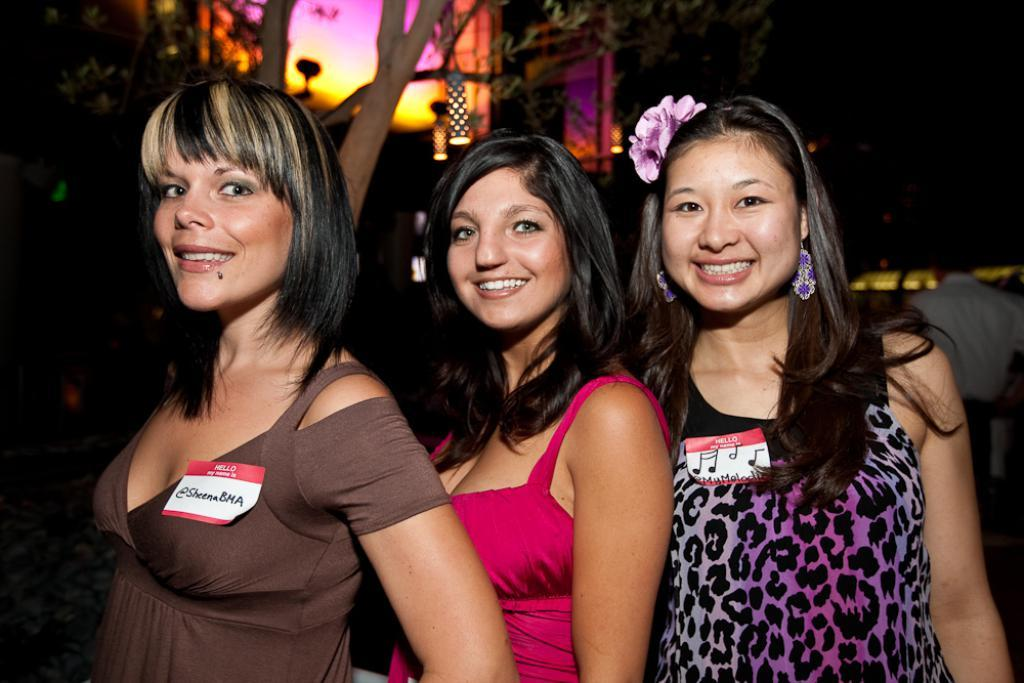How many women are present in the image? There are three women in the image. Where are the women positioned in relation to the image? The women are standing in the front. What can be seen in the background of the image? There are trees and lights in the background of the image. What is the color of the dress worn by one of the women? One of the women is wearing a pink dress. Can you describe the stone structure near the river in the image? There is no stone structure or river present in the image; it features in the image include three women, trees, and lights in the background. 